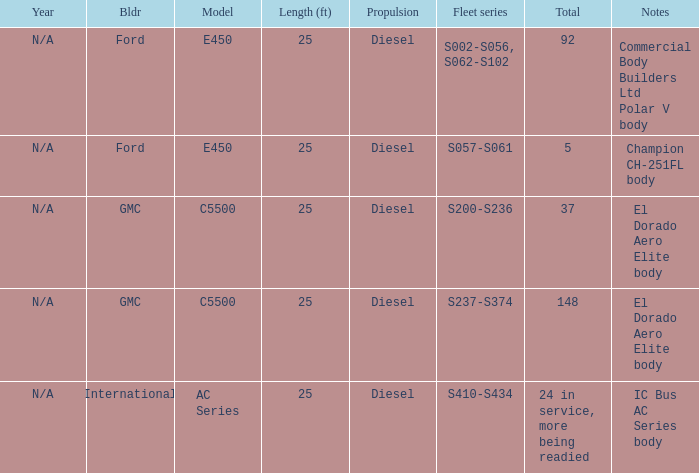How many international builders are there? 24 in service, more being readied. 